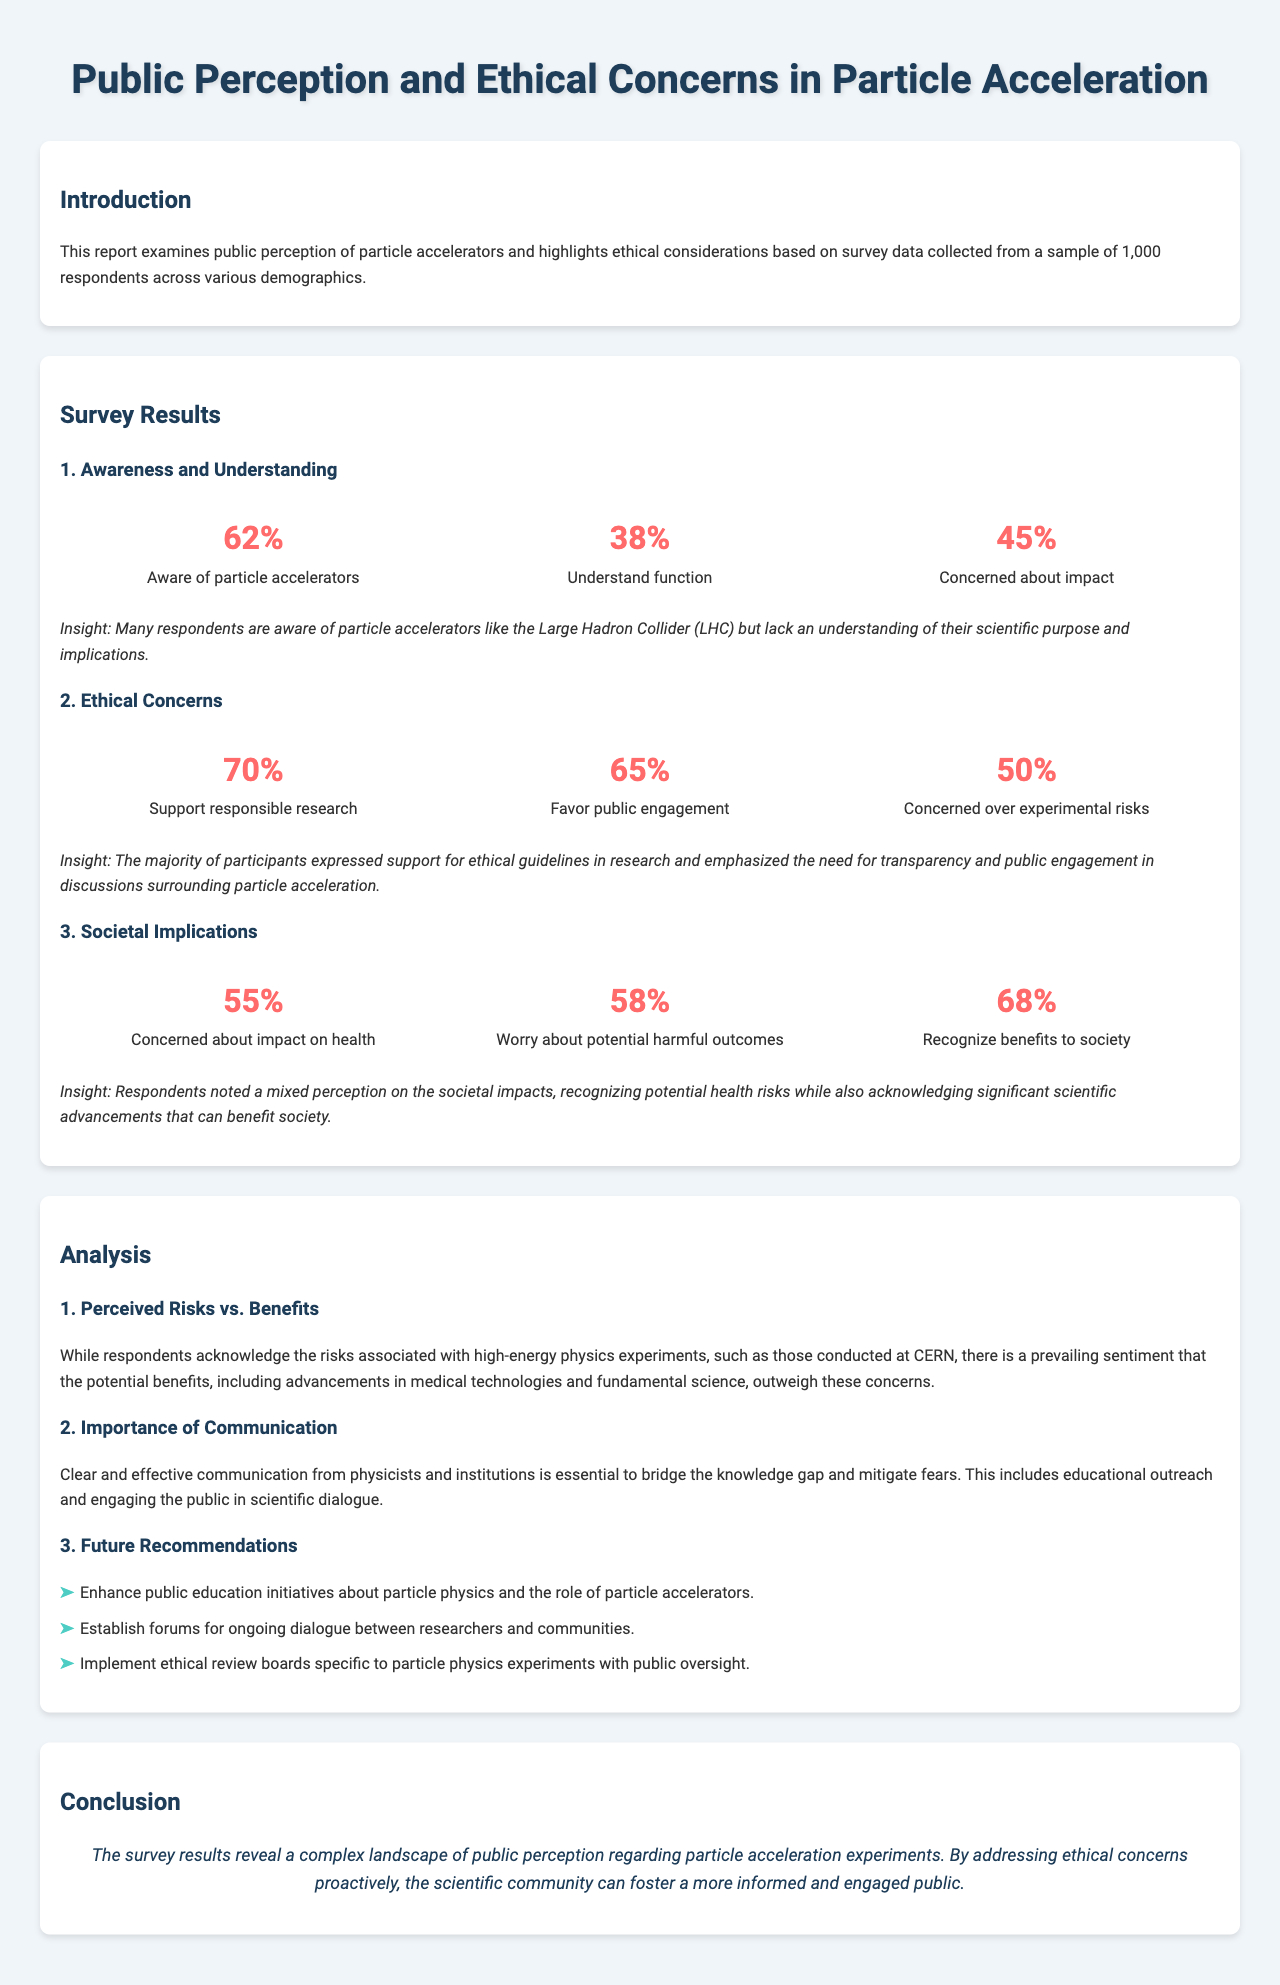What percentage of respondents are aware of particle accelerators? The document states that 62% of respondents are aware of particle accelerators.
Answer: 62% What percentage of respondents understand the function of particle accelerators? According to the survey results, 38% of respondents understand the function of particle accelerators.
Answer: 38% What is the primary ethical concern expressed by 50% of respondents? The document indicates that 50% of respondents are concerned over experimental risks.
Answer: Experimental risks What percentage of respondents recognize benefits to society from particle acceleration? The report mentions that 68% of respondents recognize benefits to society.
Answer: 68% What is suggested as essential for bridging the knowledge gap regarding particle physics? The document states that clear and effective communication is essential for bridging the knowledge gap.
Answer: Communication What percentage of respondents support responsible research according to the ethical concerns section? It is noted in the report that 70% of respondents support responsible research.
Answer: 70% What key aspect is emphasized for future recommendations in the analysis section? The document emphasizes the importance of public education initiatives.
Answer: Public education initiatives What are participants' mixed feelings regarding societal impacts? Participants noted both health risks and significant scientific advancements.
Answer: Health risks and scientific advancements 